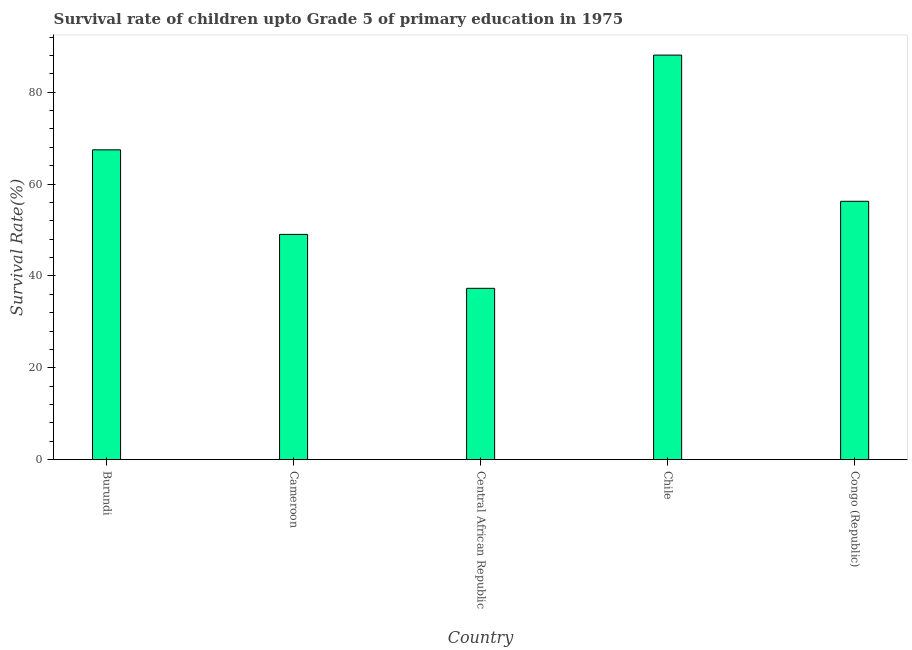Does the graph contain grids?
Your answer should be very brief. No. What is the title of the graph?
Offer a very short reply. Survival rate of children upto Grade 5 of primary education in 1975 . What is the label or title of the X-axis?
Your answer should be compact. Country. What is the label or title of the Y-axis?
Your answer should be very brief. Survival Rate(%). What is the survival rate in Cameroon?
Your answer should be compact. 49.04. Across all countries, what is the maximum survival rate?
Your answer should be compact. 88.07. Across all countries, what is the minimum survival rate?
Provide a succinct answer. 37.31. In which country was the survival rate maximum?
Ensure brevity in your answer.  Chile. In which country was the survival rate minimum?
Ensure brevity in your answer.  Central African Republic. What is the sum of the survival rate?
Ensure brevity in your answer.  298.13. What is the difference between the survival rate in Burundi and Cameroon?
Keep it short and to the point. 18.41. What is the average survival rate per country?
Provide a succinct answer. 59.62. What is the median survival rate?
Your answer should be compact. 56.25. In how many countries, is the survival rate greater than 48 %?
Offer a terse response. 4. What is the ratio of the survival rate in Chile to that in Congo (Republic)?
Provide a succinct answer. 1.57. Is the survival rate in Cameroon less than that in Central African Republic?
Offer a very short reply. No. What is the difference between the highest and the second highest survival rate?
Provide a succinct answer. 20.62. What is the difference between the highest and the lowest survival rate?
Make the answer very short. 50.77. Are all the bars in the graph horizontal?
Make the answer very short. No. Are the values on the major ticks of Y-axis written in scientific E-notation?
Provide a short and direct response. No. What is the Survival Rate(%) of Burundi?
Your response must be concise. 67.45. What is the Survival Rate(%) of Cameroon?
Offer a terse response. 49.04. What is the Survival Rate(%) in Central African Republic?
Your answer should be very brief. 37.31. What is the Survival Rate(%) of Chile?
Your response must be concise. 88.07. What is the Survival Rate(%) in Congo (Republic)?
Ensure brevity in your answer.  56.25. What is the difference between the Survival Rate(%) in Burundi and Cameroon?
Make the answer very short. 18.41. What is the difference between the Survival Rate(%) in Burundi and Central African Republic?
Your answer should be compact. 30.14. What is the difference between the Survival Rate(%) in Burundi and Chile?
Give a very brief answer. -20.62. What is the difference between the Survival Rate(%) in Burundi and Congo (Republic)?
Offer a very short reply. 11.2. What is the difference between the Survival Rate(%) in Cameroon and Central African Republic?
Give a very brief answer. 11.74. What is the difference between the Survival Rate(%) in Cameroon and Chile?
Your response must be concise. -39.03. What is the difference between the Survival Rate(%) in Cameroon and Congo (Republic)?
Offer a very short reply. -7.21. What is the difference between the Survival Rate(%) in Central African Republic and Chile?
Give a very brief answer. -50.77. What is the difference between the Survival Rate(%) in Central African Republic and Congo (Republic)?
Offer a terse response. -18.94. What is the difference between the Survival Rate(%) in Chile and Congo (Republic)?
Your response must be concise. 31.82. What is the ratio of the Survival Rate(%) in Burundi to that in Cameroon?
Your response must be concise. 1.38. What is the ratio of the Survival Rate(%) in Burundi to that in Central African Republic?
Provide a short and direct response. 1.81. What is the ratio of the Survival Rate(%) in Burundi to that in Chile?
Ensure brevity in your answer.  0.77. What is the ratio of the Survival Rate(%) in Burundi to that in Congo (Republic)?
Make the answer very short. 1.2. What is the ratio of the Survival Rate(%) in Cameroon to that in Central African Republic?
Give a very brief answer. 1.31. What is the ratio of the Survival Rate(%) in Cameroon to that in Chile?
Make the answer very short. 0.56. What is the ratio of the Survival Rate(%) in Cameroon to that in Congo (Republic)?
Keep it short and to the point. 0.87. What is the ratio of the Survival Rate(%) in Central African Republic to that in Chile?
Your answer should be very brief. 0.42. What is the ratio of the Survival Rate(%) in Central African Republic to that in Congo (Republic)?
Make the answer very short. 0.66. What is the ratio of the Survival Rate(%) in Chile to that in Congo (Republic)?
Ensure brevity in your answer.  1.57. 